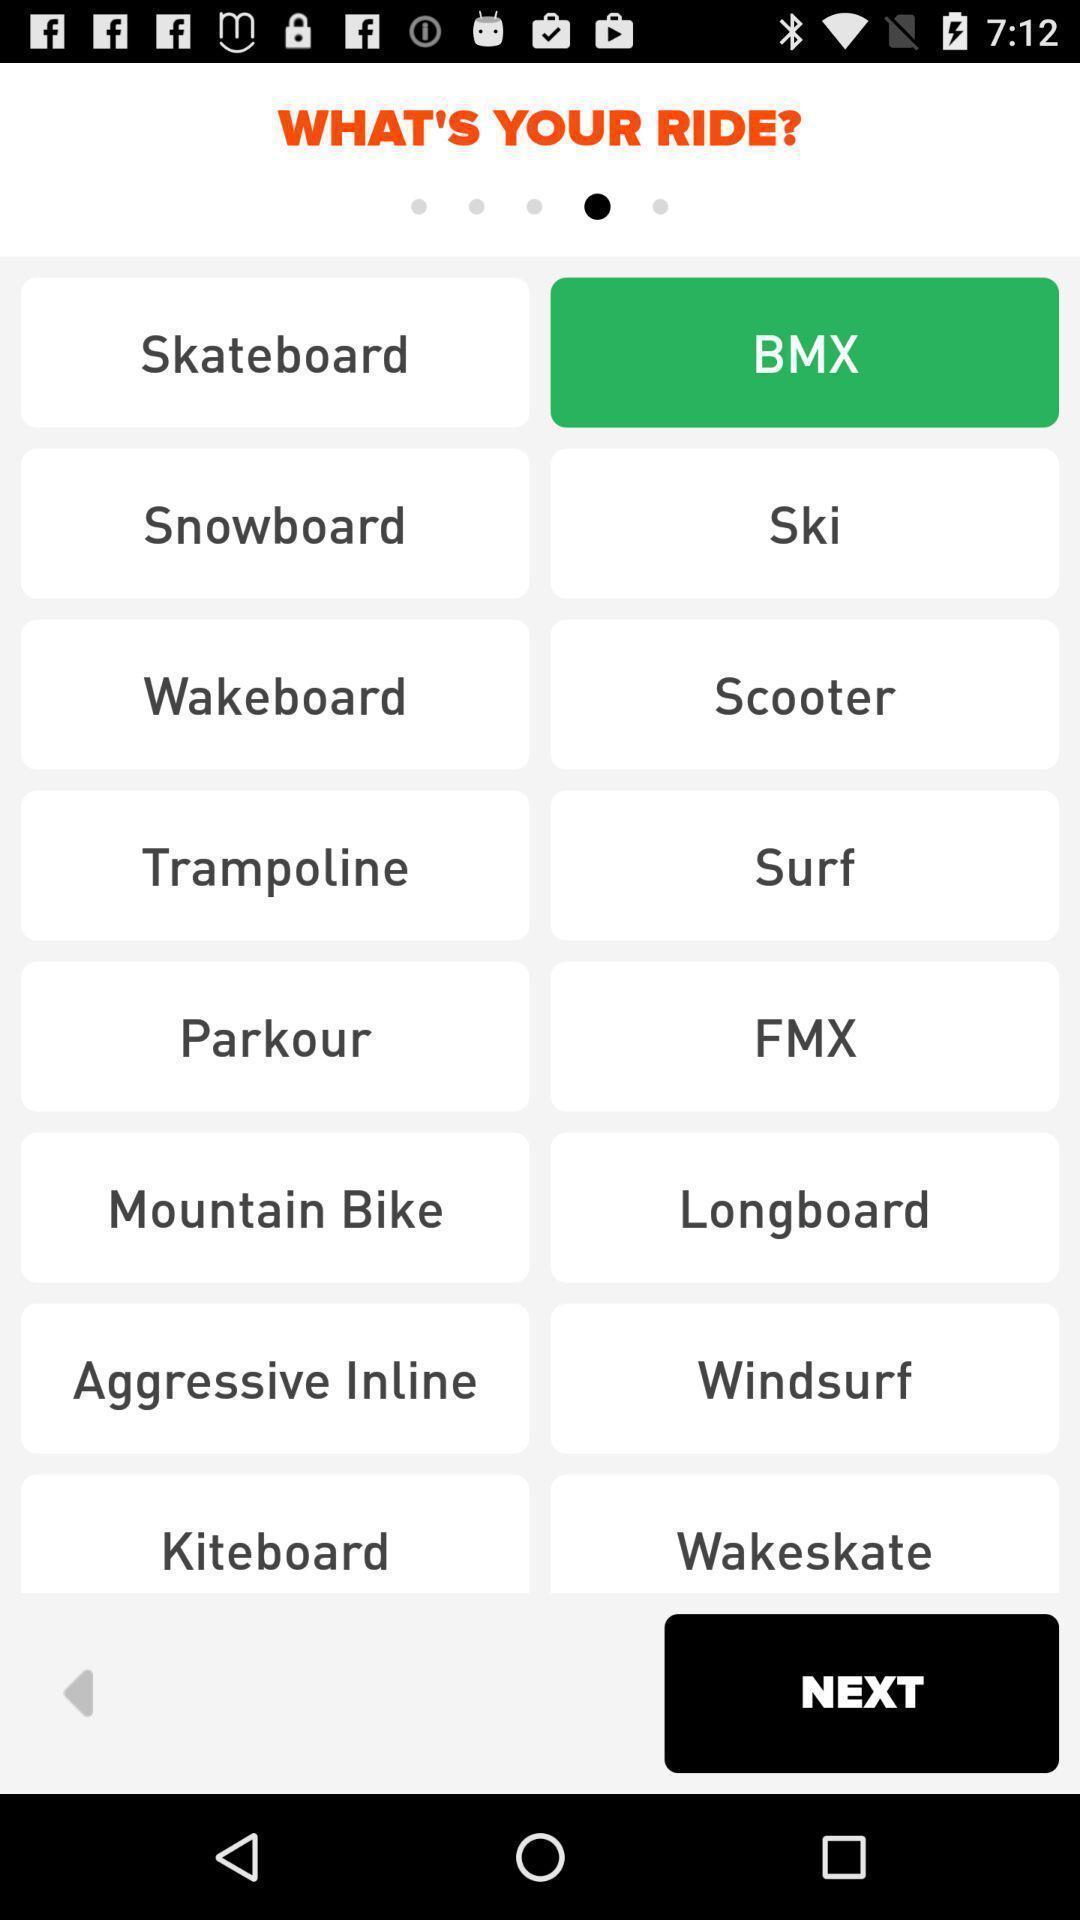Tell me about the visual elements in this screen capture. Screen displaying list of rides. 